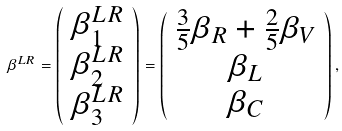Convert formula to latex. <formula><loc_0><loc_0><loc_500><loc_500>\beta ^ { L R } = \left ( \begin{array} { c } \beta _ { 1 } ^ { L R } \\ \beta _ { 2 } ^ { L R } \\ \beta _ { 3 } ^ { L R } \end{array} \right ) = \left ( \begin{array} { c } \frac { 3 } { 5 } \beta _ { R } + \frac { 2 } { 5 } \beta _ { V } \\ \beta _ { L } \\ \beta _ { C } \end{array} \right ) ,</formula> 